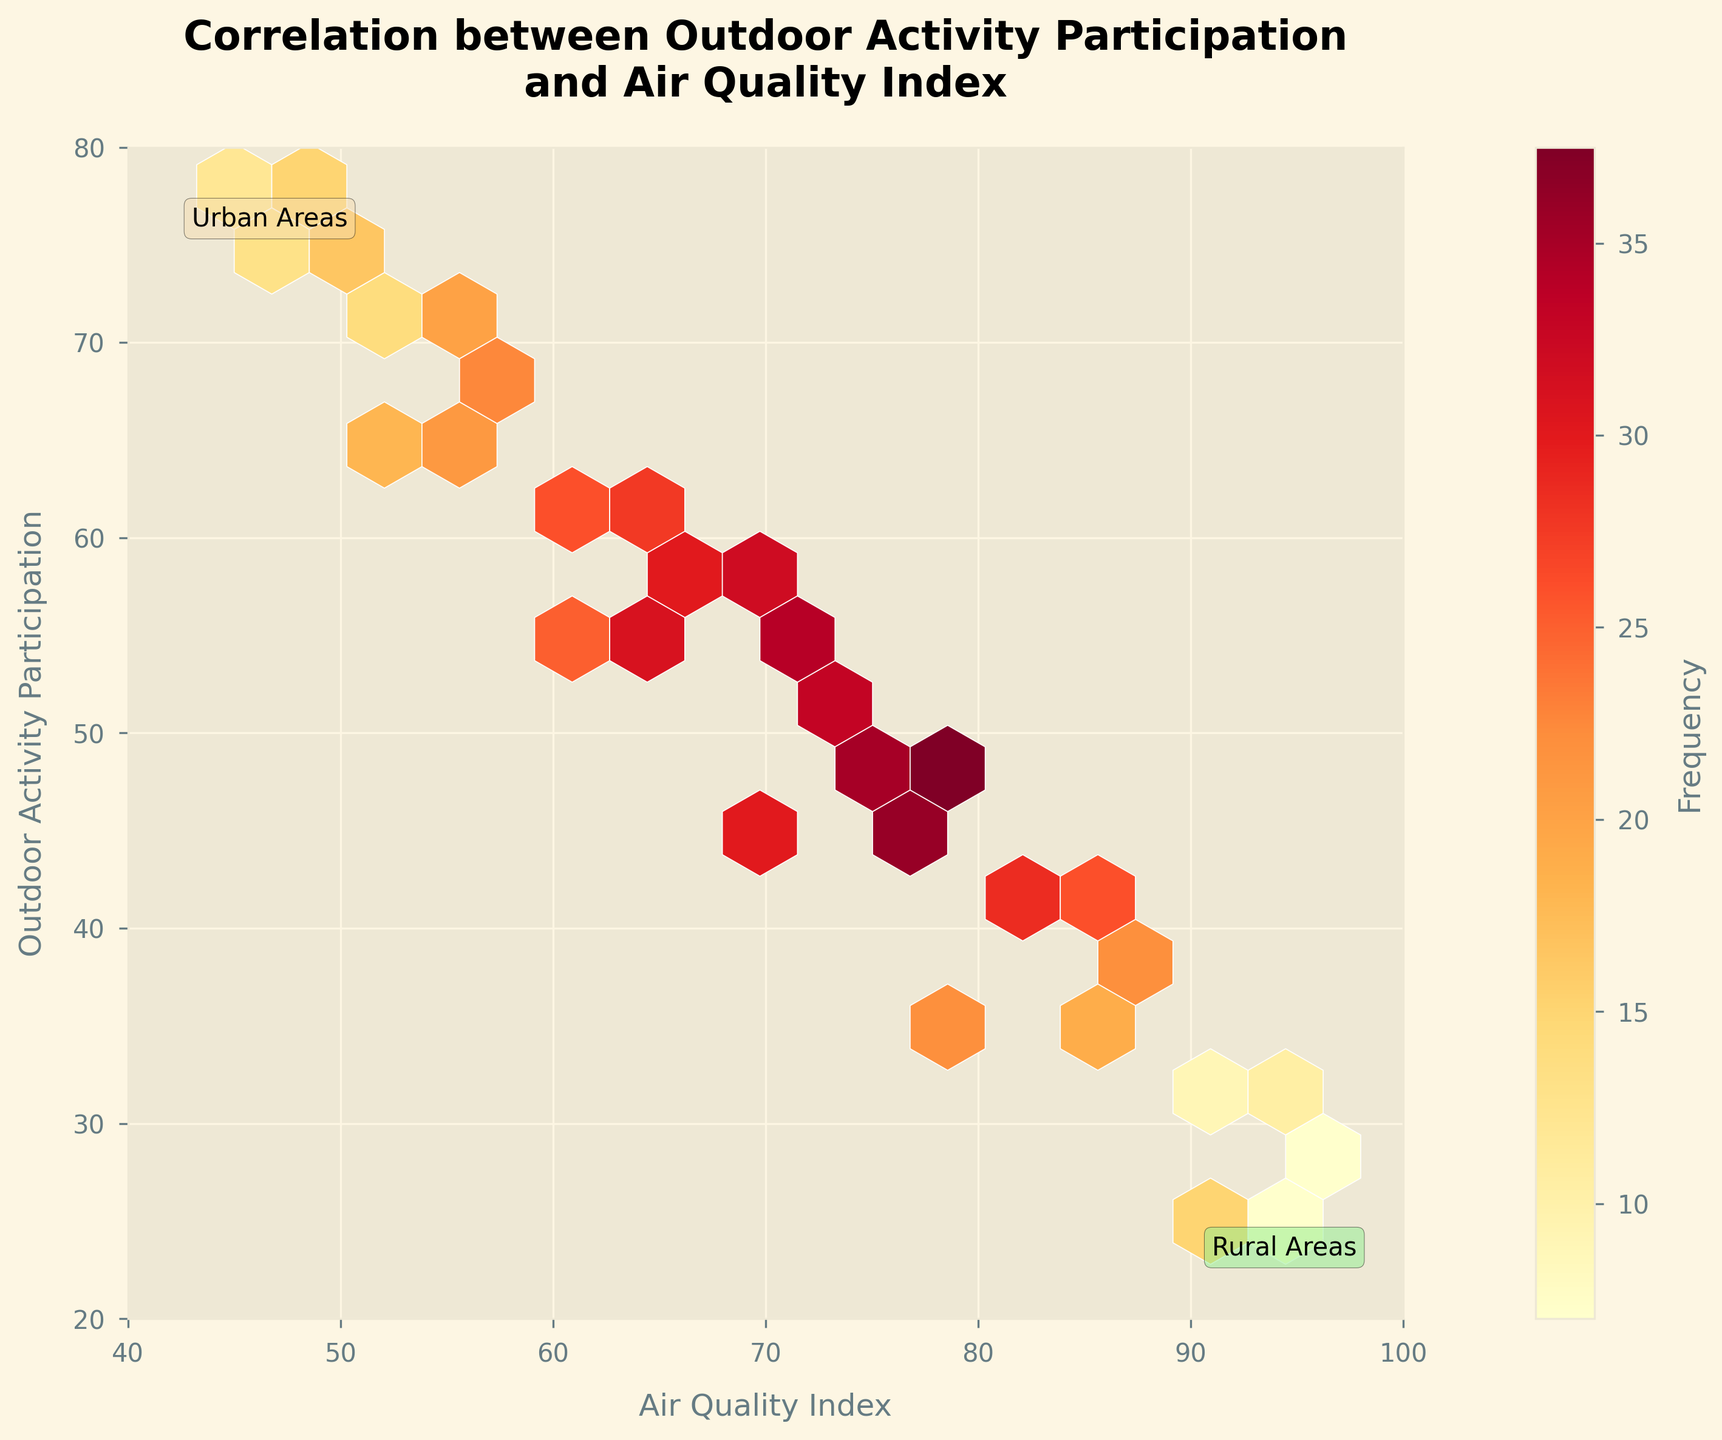what does the figure title convey? The title "Correlation between Outdoor Activity Participation and Air Quality Index" indicates that the plot is showing the relationship between the air quality index and the frequency of outdoor activities.
Answer: Correlation between Outdoor Activity Participation and Air Quality Index What does the color intensity in the hexagons represent? The color intensity in the hexagons represents the frequency of data points within that specific area. Darker colors denote higher frequencies.
Answer: Frequency What are the ranges for the x-axis and y-axis? The x-axis represents the Air Quality Index ranging from 40 to 100, and the y-axis represents Outdoor Activity Participation ranging from 20 to 80.
Answer: x: 40-100, y: 20-80 How more frequent are outdoor activities in rural areas with an air quality index around 50? In rural areas with an air quality index around 50, the combined counts from the relevant hexagons add up to a frequent occurrence. Specifically, hexagons around (50, 75), (48, 76), (49, 77), and (45, 78) show frequencies of 16, 13, 15, and 12 respectively. Summing these gives a total frequency of 56.
Answer: 56 What can be deduced about the correlation between air quality index and outdoor activity participation? The hexbin plot shows that frequencies are higher in areas where the air quality index is lower (on the left of the plot) and outdoor activity participation is higher (near the top), suggesting a potential inverse correlation between air quality and outdoor activity.
Answer: Potential inverse correlation Is outdoor activity participation higher in urban areas with an air quality index around 80 or in rural areas with an air quality index around 70? By comparing the frequencies, hexagons around (80, 35) in urban areas have a total frequency of 22, while hexagons around (70, 45) in rural areas have a total frequency of 30. Thus, outdoor activity participation is higher in rural areas with an air quality index around 70.
Answer: Rural areas with AQI around 70 What is the highest frequency value on the plot and where is it located? The highest frequency value on the plot is 38 and it is located at the hexagon around (78, 48).
Answer: 38, (78, 48) How does the frequency of outdoor activities change as the air quality index improves from 50 to 95? From the plot, we observe a trend where higher frequencies are concentrated at lower air quality indices (50-78), and the frequency decreases as the air quality index improves towards 95.
Answer: Frequency decreases with improving AQI How frequent are outdoor activities in urban areas when the air quality index is 85? The hexbin around (85, 40) shows the frequency count as 26, indicating the occurrence of outdoor activities in urban areas with an air quality index of 85.
Answer: 26 Would you say there are more frequent outdoor activities in urban or rural areas based on the data distribution? Based on the color intensity and distribution, rural areas (on the left of the plot) exhibit more frequent outdoor activities compared to urban areas (on the right), suggesting outdoor activities are more frequent in rural settings.
Answer: Rural areas 